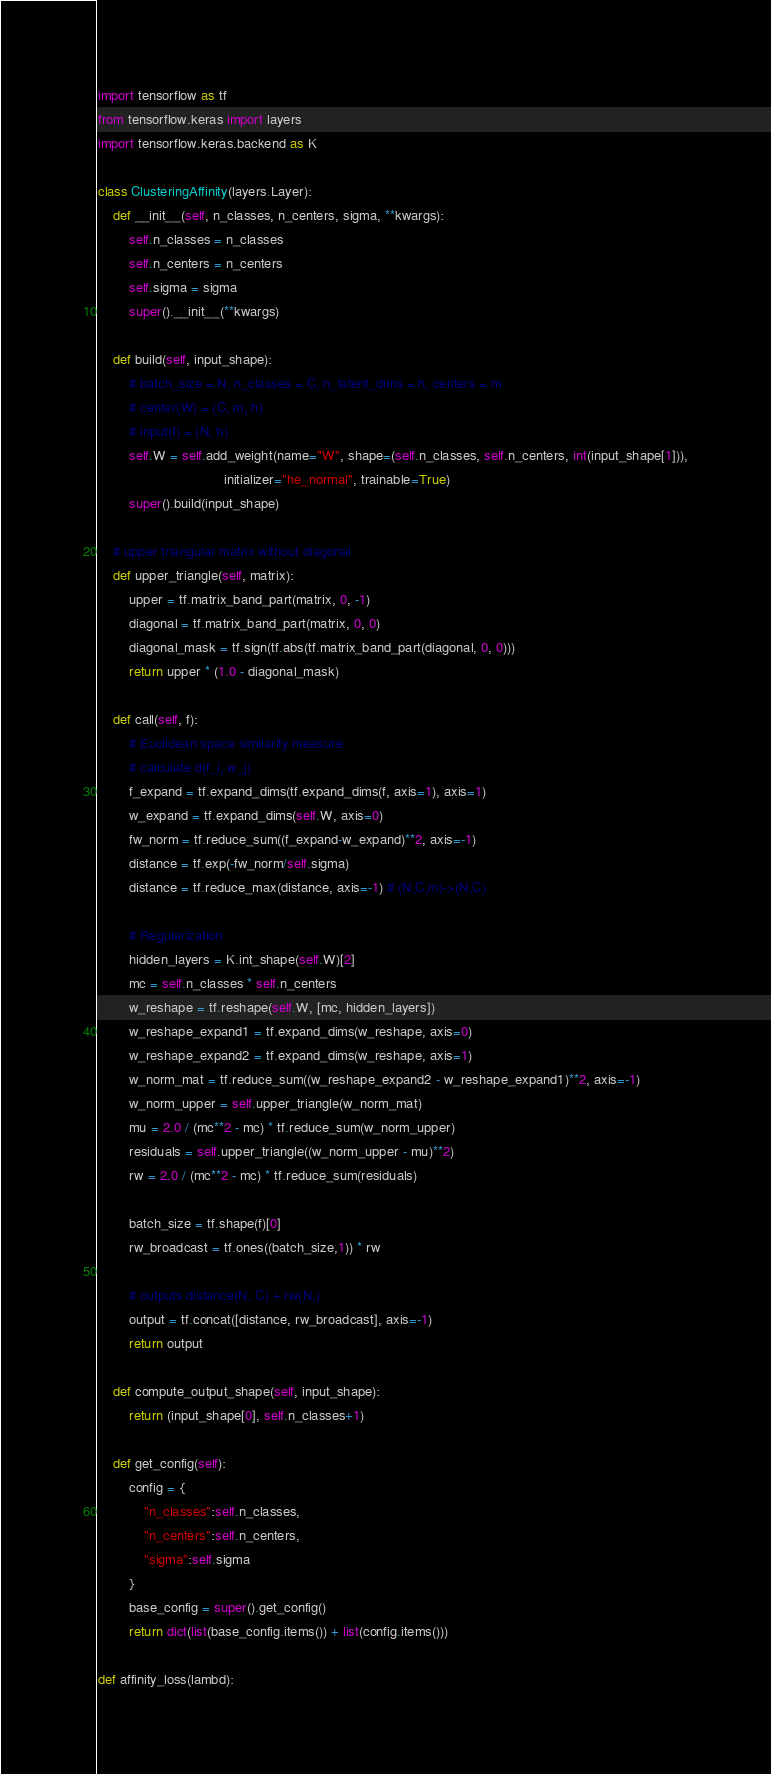<code> <loc_0><loc_0><loc_500><loc_500><_Python_>import tensorflow as tf
from tensorflow.keras import layers
import tensorflow.keras.backend as K

class ClusteringAffinity(layers.Layer):
    def __init__(self, n_classes, n_centers, sigma, **kwargs):
        self.n_classes = n_classes
        self.n_centers = n_centers
        self.sigma = sigma
        super().__init__(**kwargs)

    def build(self, input_shape):
        # batch_size = N, n_classes = C, n_latent_dims = h, centers = m
        # center(W) = (C, m, h)
        # input(f) = (N, h)
        self.W = self.add_weight(name="W", shape=(self.n_classes, self.n_centers, int(input_shape[1])),
                                 initializer="he_normal", trainable=True)
        super().build(input_shape)

    # upper triangular matrix without diagonal
    def upper_triangle(self, matrix):
        upper = tf.matrix_band_part(matrix, 0, -1)
        diagonal = tf.matrix_band_part(matrix, 0, 0)
        diagonal_mask = tf.sign(tf.abs(tf.matrix_band_part(diagonal, 0, 0)))
        return upper * (1.0 - diagonal_mask)

    def call(self, f):
        # Euclidean space similarity measure
        # calculate d(f_i, w_j)
        f_expand = tf.expand_dims(tf.expand_dims(f, axis=1), axis=1)
        w_expand = tf.expand_dims(self.W, axis=0)
        fw_norm = tf.reduce_sum((f_expand-w_expand)**2, axis=-1)
        distance = tf.exp(-fw_norm/self.sigma)
        distance = tf.reduce_max(distance, axis=-1) # (N,C,m)->(N,C)

        # Regularization
        hidden_layers = K.int_shape(self.W)[2]
        mc = self.n_classes * self.n_centers
        w_reshape = tf.reshape(self.W, [mc, hidden_layers])
        w_reshape_expand1 = tf.expand_dims(w_reshape, axis=0)
        w_reshape_expand2 = tf.expand_dims(w_reshape, axis=1)
        w_norm_mat = tf.reduce_sum((w_reshape_expand2 - w_reshape_expand1)**2, axis=-1)
        w_norm_upper = self.upper_triangle(w_norm_mat)
        mu = 2.0 / (mc**2 - mc) * tf.reduce_sum(w_norm_upper)
        residuals = self.upper_triangle((w_norm_upper - mu)**2)
        rw = 2.0 / (mc**2 - mc) * tf.reduce_sum(residuals)

        batch_size = tf.shape(f)[0]
        rw_broadcast = tf.ones((batch_size,1)) * rw

        # outputs distance(N, C) + rw(N,)
        output = tf.concat([distance, rw_broadcast], axis=-1)
        return output

    def compute_output_shape(self, input_shape):
        return (input_shape[0], self.n_classes+1)

    def get_config(self):
        config = {
            "n_classes":self.n_classes,
            "n_centers":self.n_centers,
            "sigma":self.sigma
        }
        base_config = super().get_config()
        return dict(list(base_config.items()) + list(config.items()))

def affinity_loss(lambd):</code> 